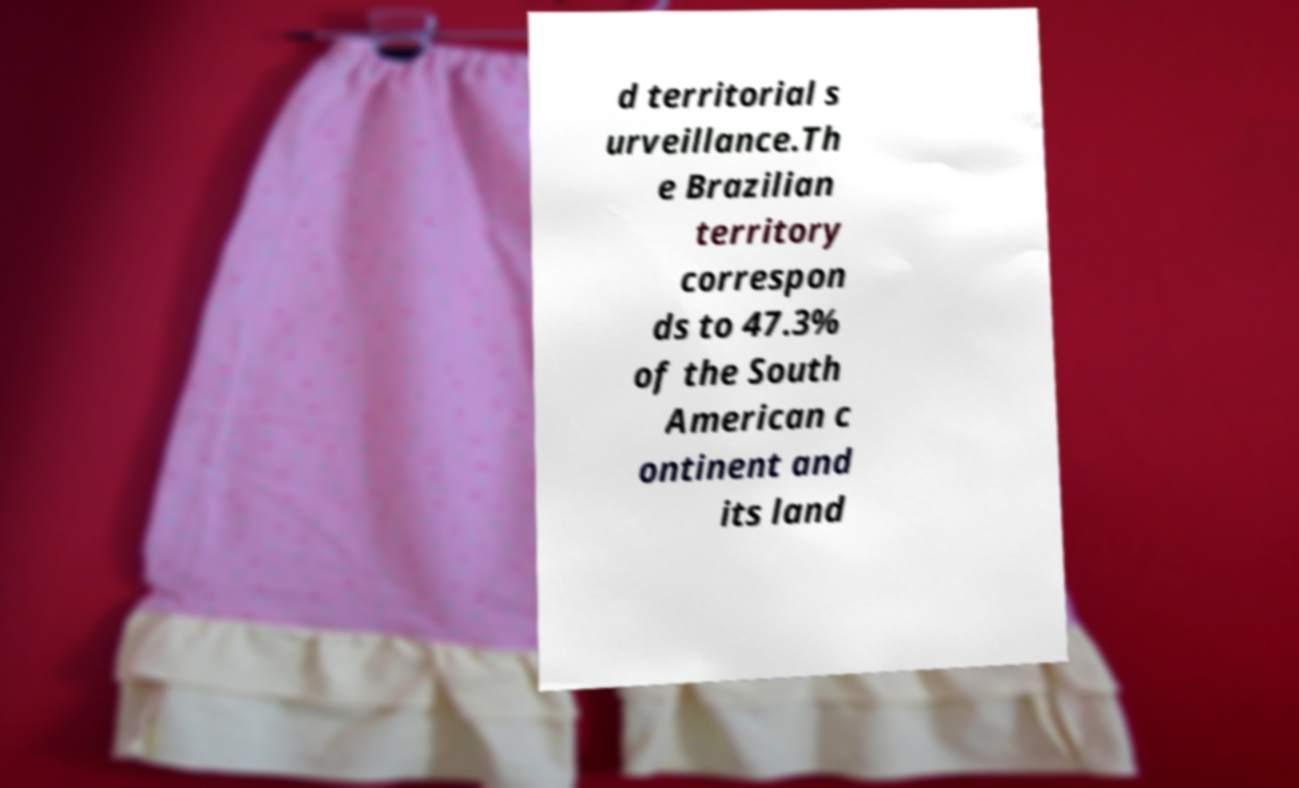I need the written content from this picture converted into text. Can you do that? d territorial s urveillance.Th e Brazilian territory correspon ds to 47.3% of the South American c ontinent and its land 